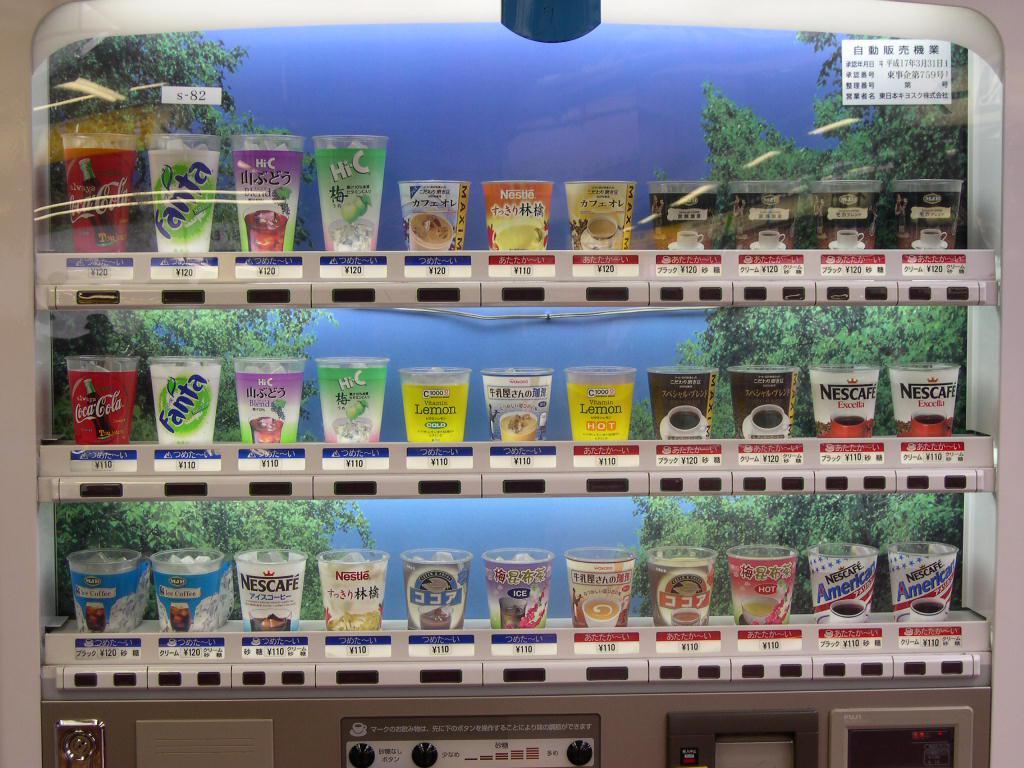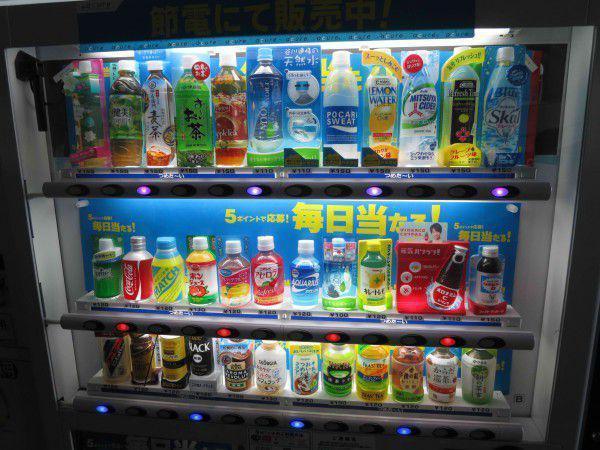The first image is the image on the left, the second image is the image on the right. For the images shown, is this caption "At least one vending machine has a background with bright blue predominant." true? Answer yes or no. Yes. 